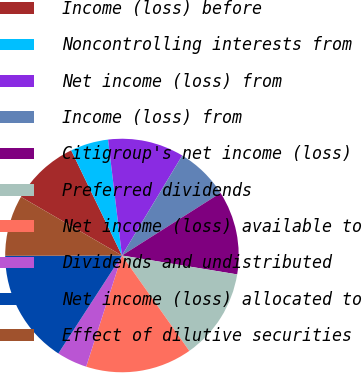<chart> <loc_0><loc_0><loc_500><loc_500><pie_chart><fcel>Income (loss) before<fcel>Noncontrolling interests from<fcel>Net income (loss) from<fcel>Income (loss) from<fcel>Citigroup's net income (loss)<fcel>Preferred dividends<fcel>Net income (loss) available to<fcel>Dividends and undistributed<fcel>Net income (loss) allocated to<fcel>Effect of dilutive securities<nl><fcel>9.47%<fcel>5.26%<fcel>10.53%<fcel>7.37%<fcel>11.58%<fcel>12.63%<fcel>14.74%<fcel>4.21%<fcel>15.79%<fcel>8.42%<nl></chart> 